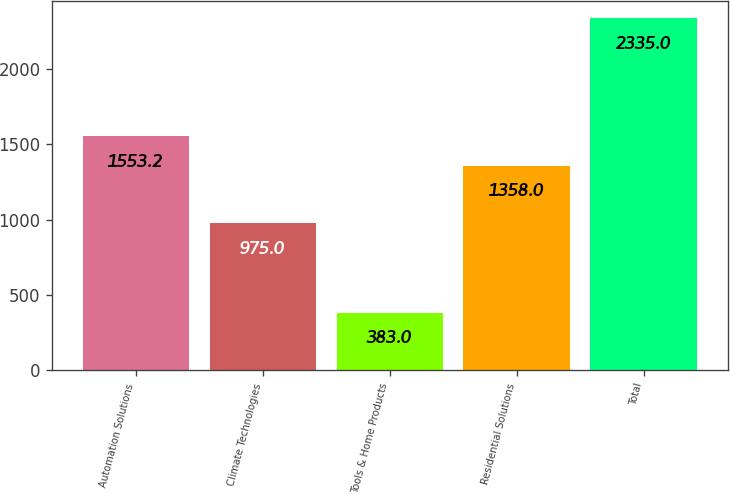<chart> <loc_0><loc_0><loc_500><loc_500><bar_chart><fcel>Automation Solutions<fcel>Climate Technologies<fcel>Tools & Home Products<fcel>Residential Solutions<fcel>Total<nl><fcel>1553.2<fcel>975<fcel>383<fcel>1358<fcel>2335<nl></chart> 